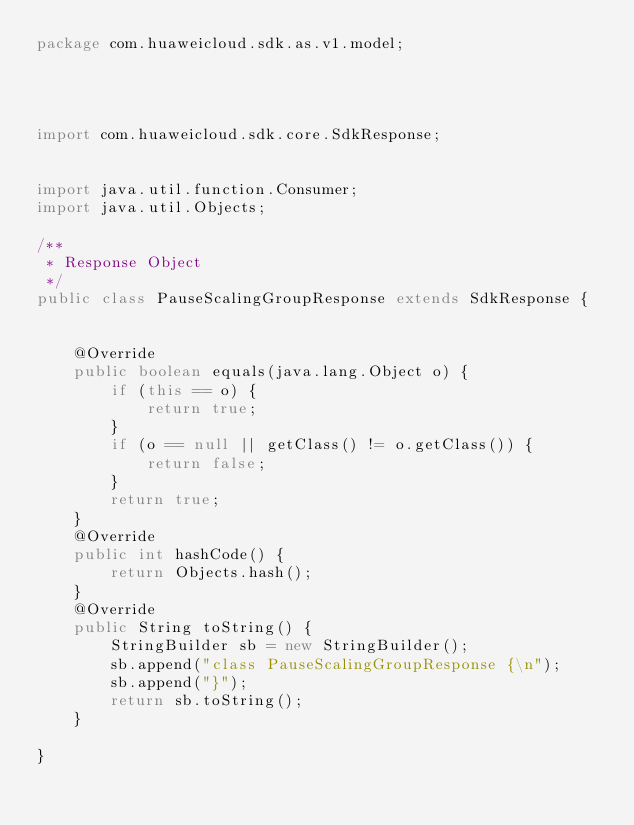<code> <loc_0><loc_0><loc_500><loc_500><_Java_>package com.huaweicloud.sdk.as.v1.model;




import com.huaweicloud.sdk.core.SdkResponse;


import java.util.function.Consumer;
import java.util.Objects;

/**
 * Response Object
 */
public class PauseScalingGroupResponse extends SdkResponse {


    @Override
    public boolean equals(java.lang.Object o) {
        if (this == o) {
            return true;
        }
        if (o == null || getClass() != o.getClass()) {
            return false;
        }
        return true;
    }
    @Override
    public int hashCode() {
        return Objects.hash();
    }
    @Override
    public String toString() {
        StringBuilder sb = new StringBuilder();
        sb.append("class PauseScalingGroupResponse {\n");
        sb.append("}");
        return sb.toString();
    }
    
}

</code> 